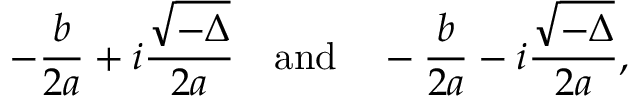<formula> <loc_0><loc_0><loc_500><loc_500>- { \frac { b } { 2 a } } + i { \frac { \sqrt { - \Delta } } { 2 a } } \quad a n d \quad - { \frac { b } { 2 a } } - i { \frac { \sqrt { - \Delta } } { 2 a } } ,</formula> 